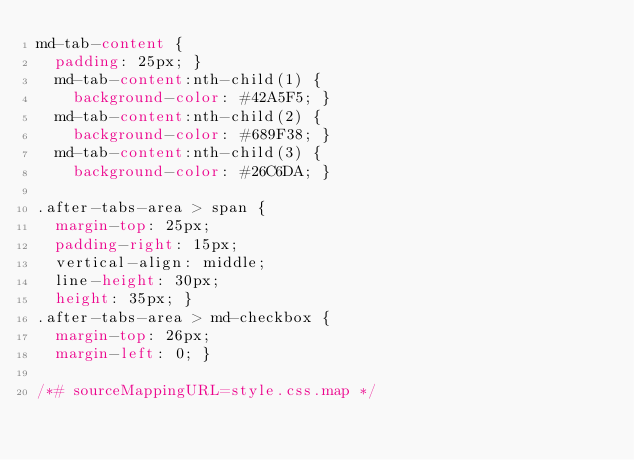Convert code to text. <code><loc_0><loc_0><loc_500><loc_500><_CSS_>md-tab-content {
  padding: 25px; }
  md-tab-content:nth-child(1) {
    background-color: #42A5F5; }
  md-tab-content:nth-child(2) {
    background-color: #689F38; }
  md-tab-content:nth-child(3) {
    background-color: #26C6DA; }

.after-tabs-area > span {
  margin-top: 25px;
  padding-right: 15px;
  vertical-align: middle;
  line-height: 30px;
  height: 35px; }
.after-tabs-area > md-checkbox {
  margin-top: 26px;
  margin-left: 0; }

/*# sourceMappingURL=style.css.map */
</code> 